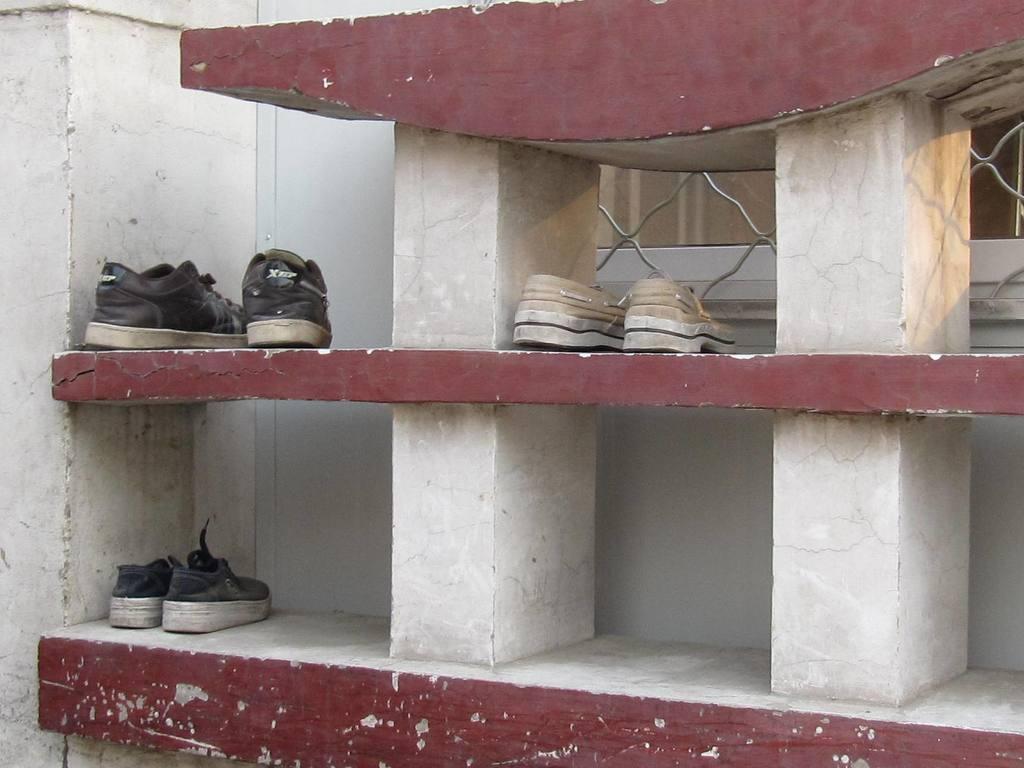In one or two sentences, can you explain what this image depicts? In this image there are three pairs of shoes arranged in an individual shelf. 